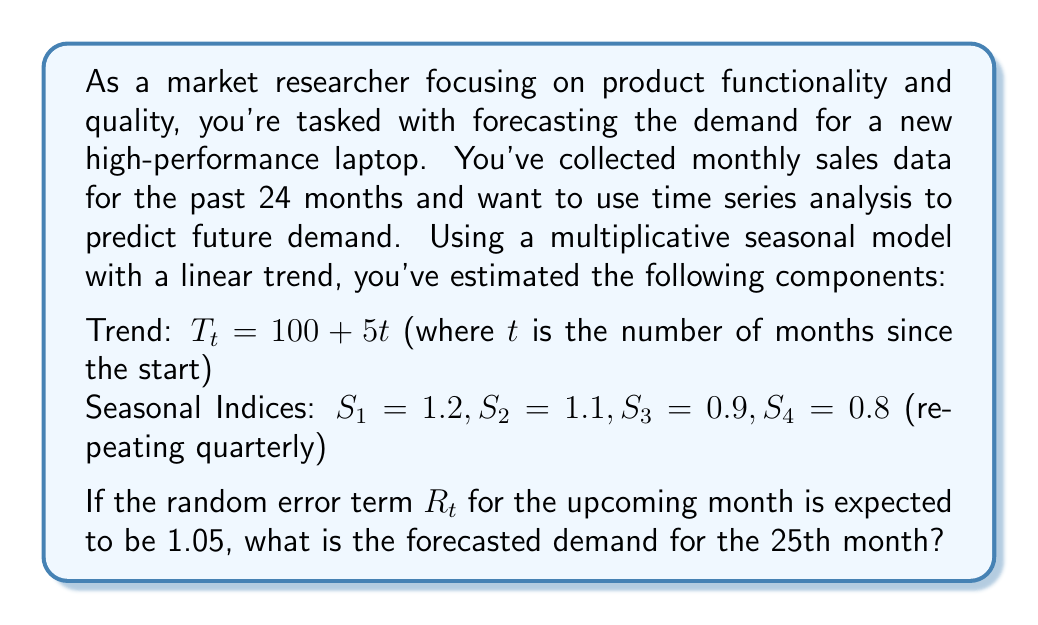What is the answer to this math problem? To solve this problem, we'll use the multiplicative seasonal model, which is given by:

$$Y_t = T_t \times S_t \times R_t$$

Where:
$Y_t$ is the forecasted demand
$T_t$ is the trend component
$S_t$ is the seasonal component
$R_t$ is the random error term

Let's break down the solution step-by-step:

1. Calculate the trend component for the 25th month:
   $$T_{25} = 100 + 5(25) = 100 + 125 = 225$$

2. Determine the appropriate seasonal index for the 25th month:
   The seasonal indices repeat quarterly, so for the 25th month, we use $S_1 = 1.2$
   (Because 25 ÷ 3 = 8 remainder 1, so it's the first month of a quarter)

3. We're given the random error term $R_{25} = 1.05$

4. Now, we can plug these values into the multiplicative seasonal model:

   $$Y_{25} = T_{25} \times S_{25} \times R_{25}$$
   $$Y_{25} = 225 \times 1.2 \times 1.05$$

5. Calculate the final result:
   $$Y_{25} = 225 \times 1.2 \times 1.05 = 283.5$$

Therefore, the forecasted demand for the 25th month is 283.5 units.
Answer: 283.5 units 